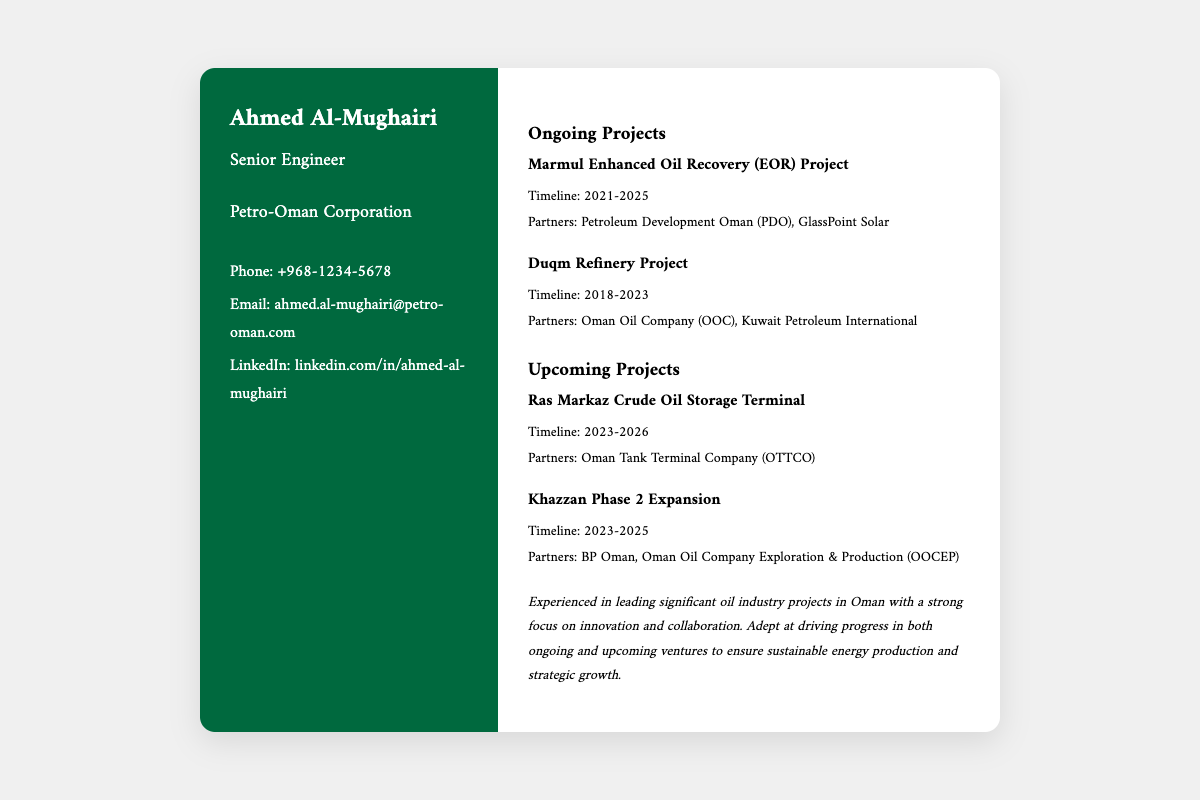what is the name of the engineer? The engineer's name is prominently displayed on the business card, which is Ahmed Al-Mughairi.
Answer: Ahmed Al-Mughairi what is the role of Ahmed Al-Mughairi? The role of Ahmed Al-Mughairi is indicated below his name on the business card, which is Senior Engineer.
Answer: Senior Engineer which company does Ahmed work for? The name of the company is stated on the business card, which is Petro-Oman Corporation.
Answer: Petro-Oman Corporation what is the timeline for the Marmul Enhanced Oil Recovery Project? The timeline is given in the project description, which is from 2021 to 2025.
Answer: 2021-2025 who are the partners in the Duqm Refinery Project? The partners for this project are listed, which are Oman Oil Company and Kuwait Petroleum International.
Answer: Oman Oil Company, Kuwait Petroleum International what is the timeline for the Ras Markaz Crude Oil Storage Terminal? The timeline for this upcoming project is provided, which is 2023 to 2026.
Answer: 2023-2026 how many ongoing projects are mentioned? The number of ongoing projects can be counted from the section, which lists two ongoing projects.
Answer: 2 what are the upcoming projects' timelines compared to ongoing projects? Upcoming projects are set for future dates, specifically from 2023 onwards, while ongoing projects started in 2021 or earlier.
Answer: 2023 onward what type of document is this? This document is specific to a business card, detailing personal and professional information.
Answer: Business Card 